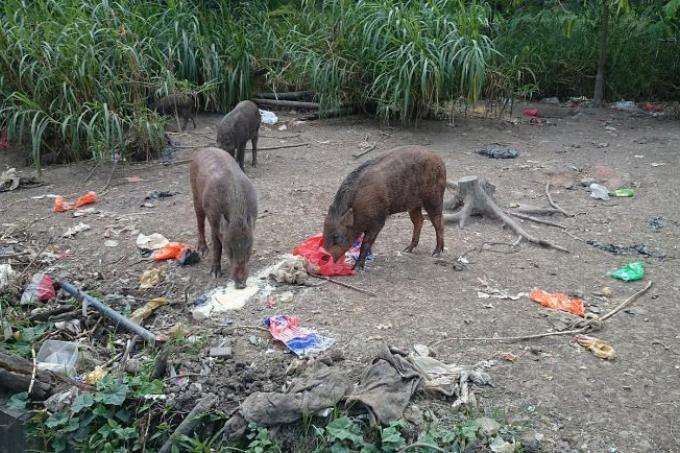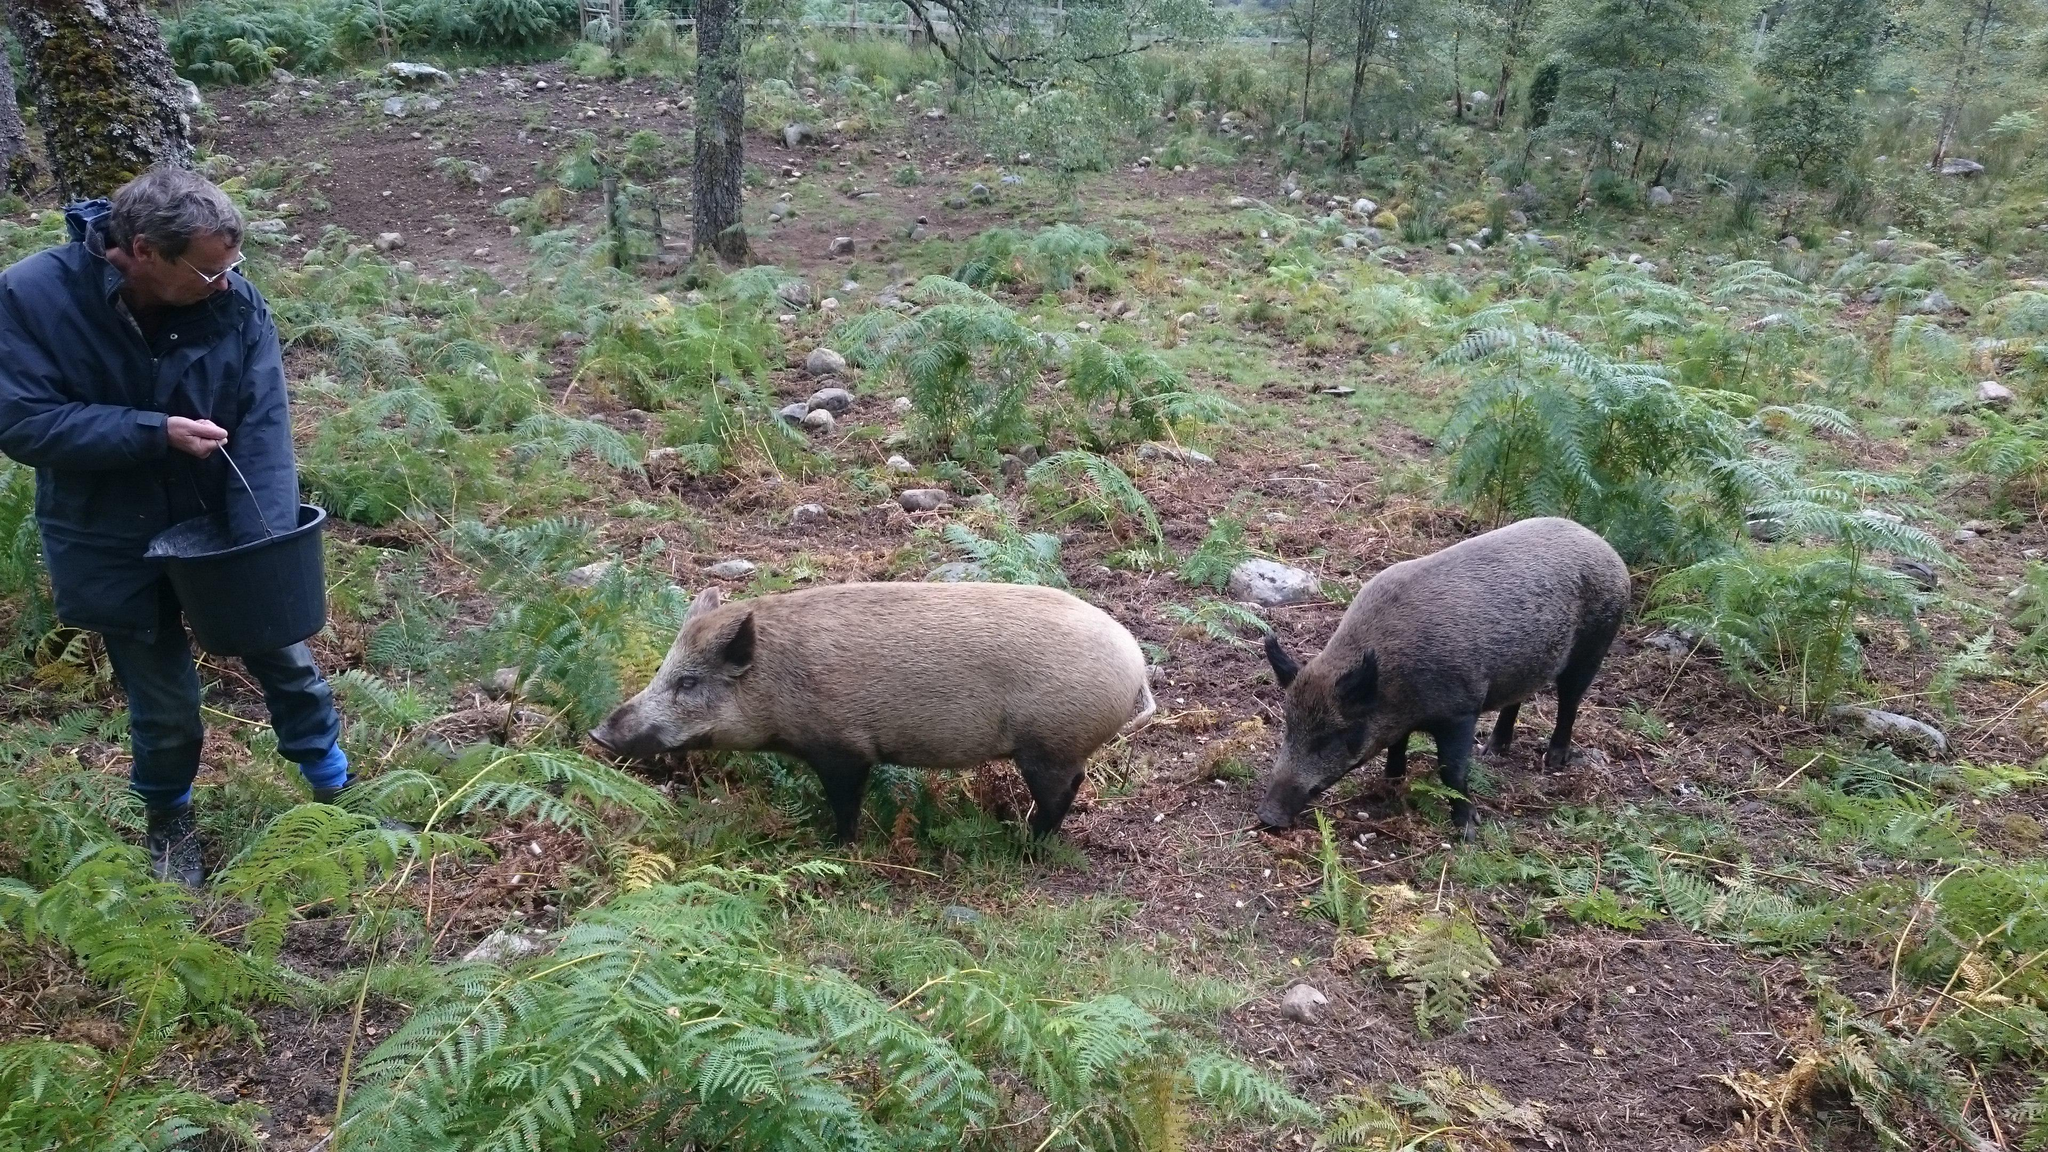The first image is the image on the left, the second image is the image on the right. For the images displayed, is the sentence "One images shows a human in close proximity to two boars." factually correct? Answer yes or no. Yes. The first image is the image on the left, the second image is the image on the right. Examine the images to the left and right. Is the description "An image shows at least one wild pig standing by a carcass." accurate? Answer yes or no. No. 